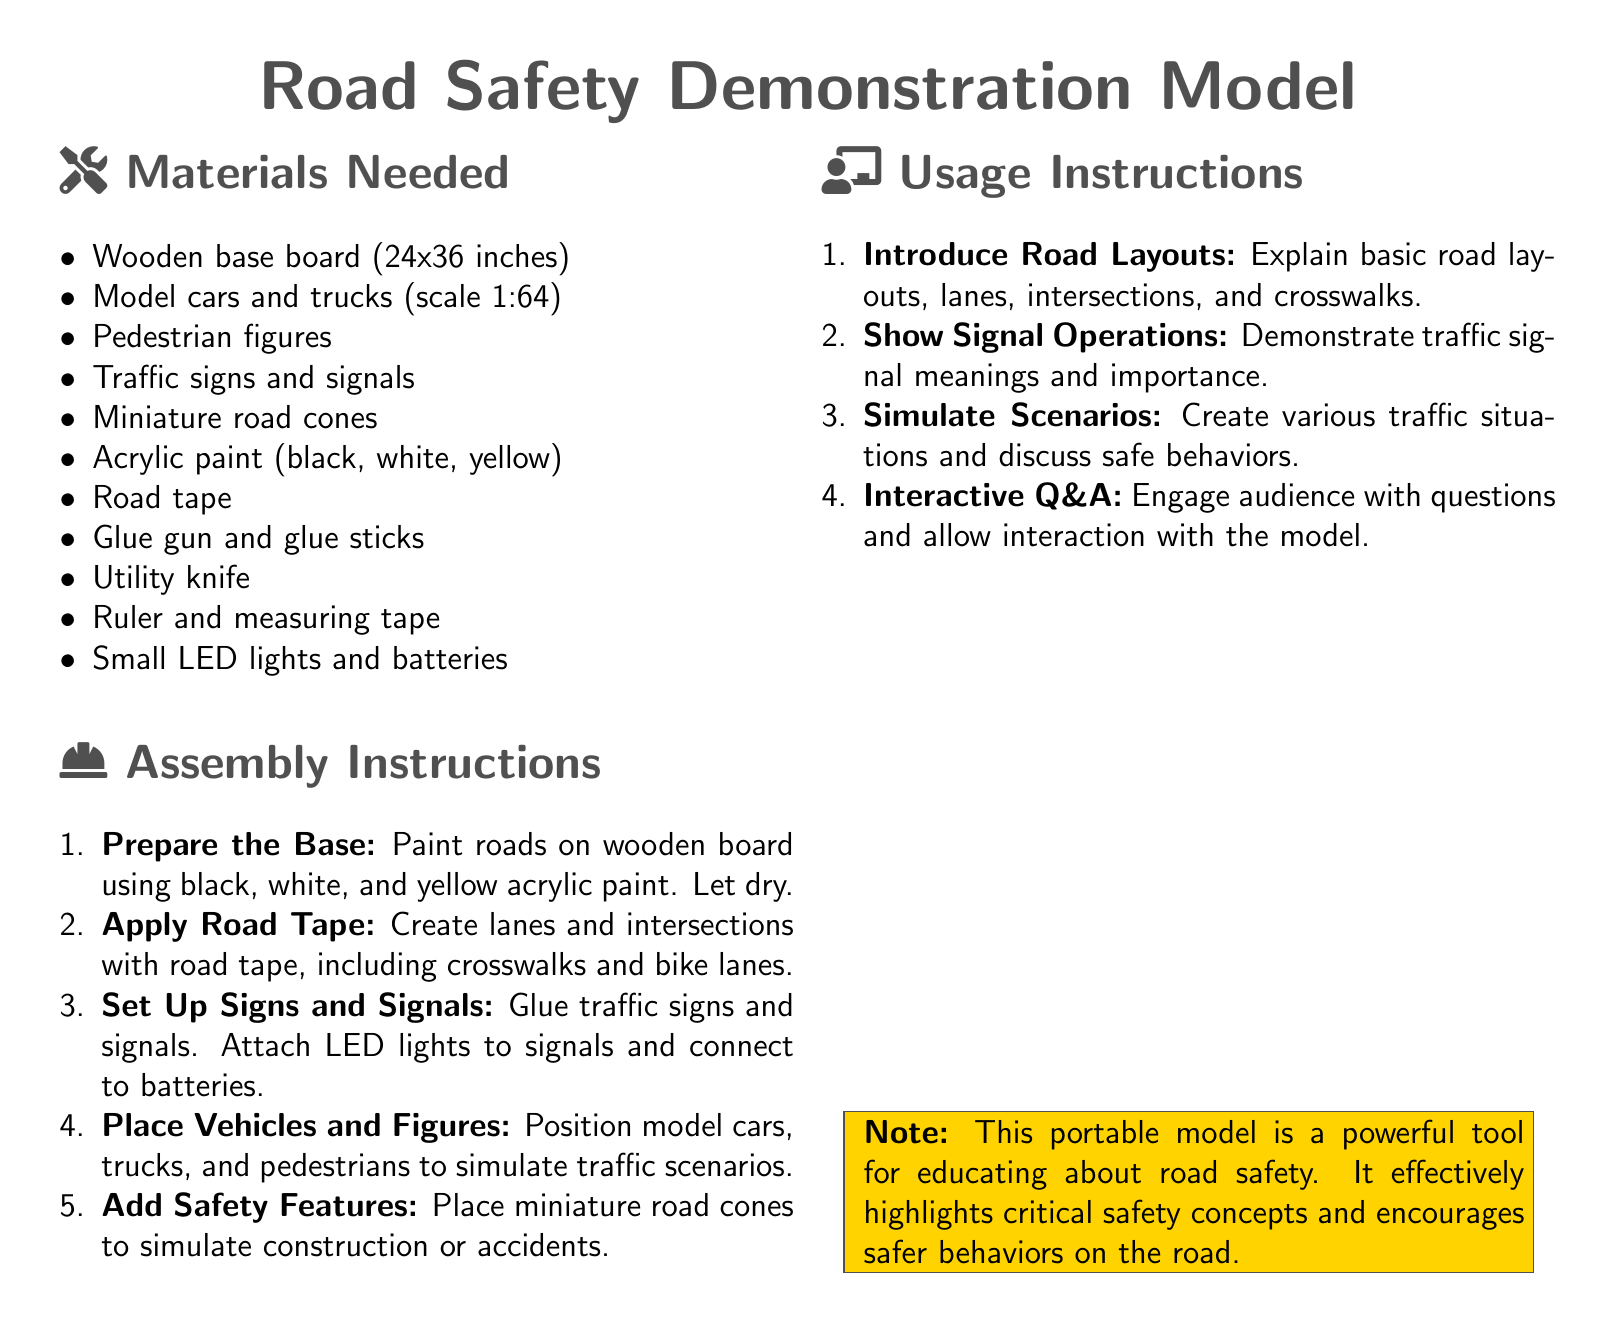What is the size of the wooden base board? The size of the wooden base board is specified in the materials needed section as 24x36 inches.
Answer: 24x36 inches How many model vehicle types are mentioned? The document lists model cars and trucks as types of vehicles, which counts as two.
Answer: 2 What is the primary color of the road paint used? The document specifies black as one of the key acrylic paint colors for the roads, making it a primary color.
Answer: Black Which tool is used for assembly in the instructions? A glue gun is listed as one of the tools needed for the assembly process in the materials section.
Answer: Glue gun What is the purpose of placing miniature road cones? The instructions indicate that miniature road cones are used to simulate construction or accidents, which serves an educational purpose.
Answer: Simulate construction or accidents What is the first step in the assembly instructions? The first step of the assembly instructions involves preparing the base by painting roads on the wooden board.
Answer: Prepare the Base How are interactive sessions encouraged in the usage instructions? Engaging the audience with questions and allowing interaction with the model is noted as part of the usage instructions.
Answer: Interactive Q&A What should be demonstrated according to the usage instructions? The usage instructions include a requirement to show signal operations and their meanings.
Answer: Signal operations What note is included about the model? The note emphasizes that this portable model serves as a powerful tool for educating about road safety.
Answer: Powerful tool for educating What are the colors listed for acrylic paint? The document specifies black, white, and yellow as the acrylic paint colors required for the project.
Answer: Black, white, yellow 